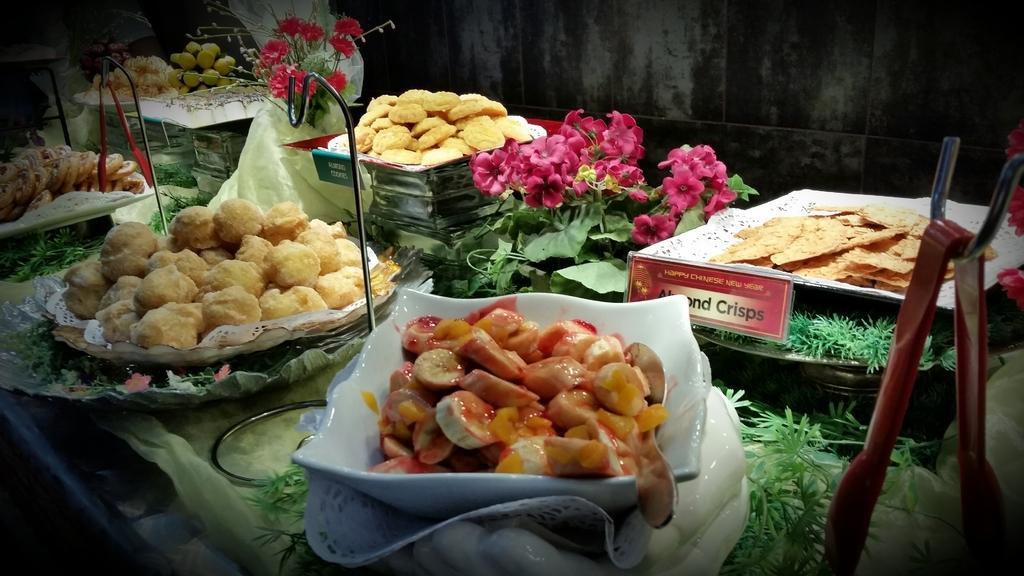Describe this image in one or two sentences. In this image there are bowls in that bowls there are food items, in the middle there are flowers. 